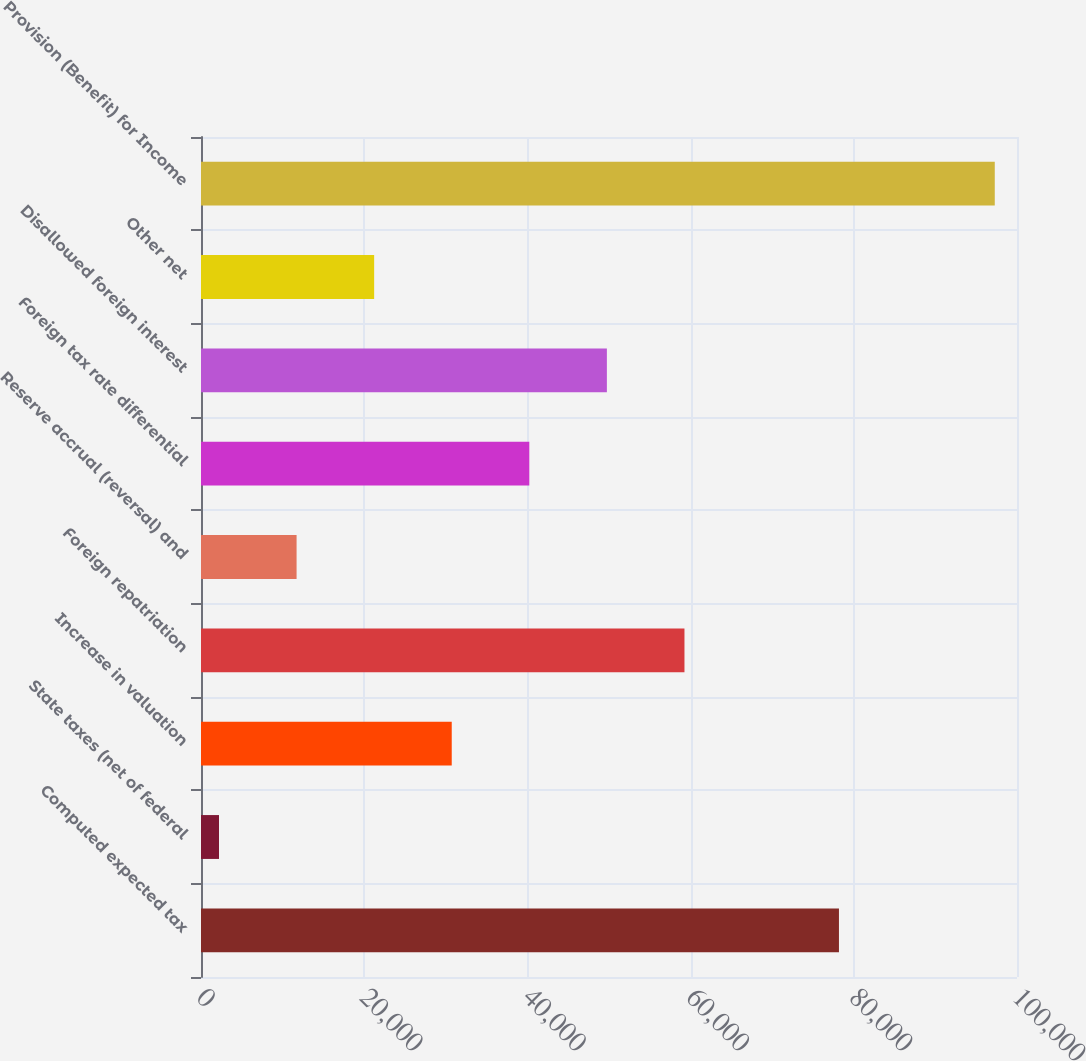Convert chart. <chart><loc_0><loc_0><loc_500><loc_500><bar_chart><fcel>Computed expected tax<fcel>State taxes (net of federal<fcel>Increase in valuation<fcel>Foreign repatriation<fcel>Reserve accrual (reversal) and<fcel>Foreign tax rate differential<fcel>Disallowed foreign interest<fcel>Other net<fcel>Provision (Benefit) for Income<nl><fcel>78181<fcel>2207<fcel>30727.4<fcel>59247.8<fcel>11713.8<fcel>40234.2<fcel>49741<fcel>21220.6<fcel>97275<nl></chart> 